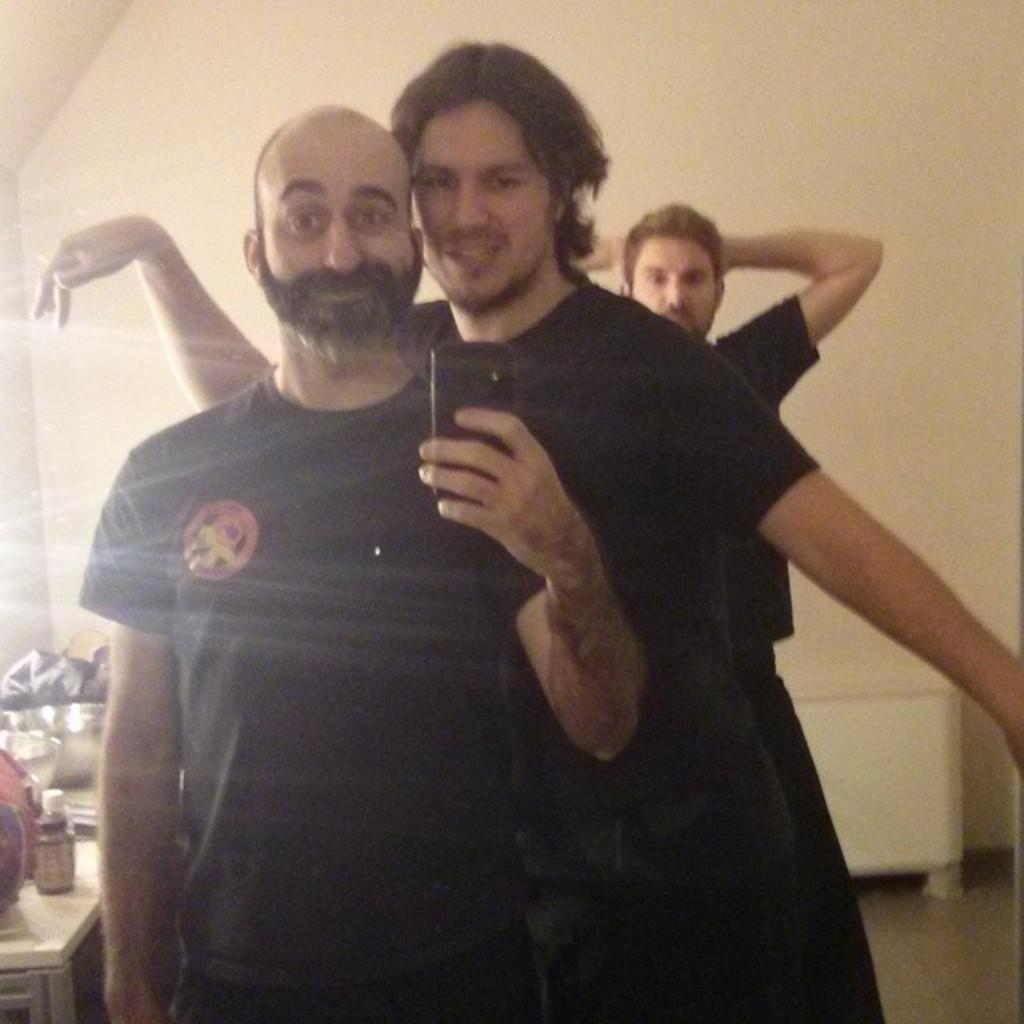What are the people in the image doing? The people in the image are standing. Can you identify any specific object that one person is holding? Yes, one person is holding a mobile phone. What can be seen on the left side of the image? There are objects on the left side of the image. What is visible beneath the people's feet in the image? The ground is visible in the image. What type of eggs can be seen in the image? There are no eggs present in the image. What joke is the person holding the mobile phone telling in the image? There is no indication of a joke being told in the image. 